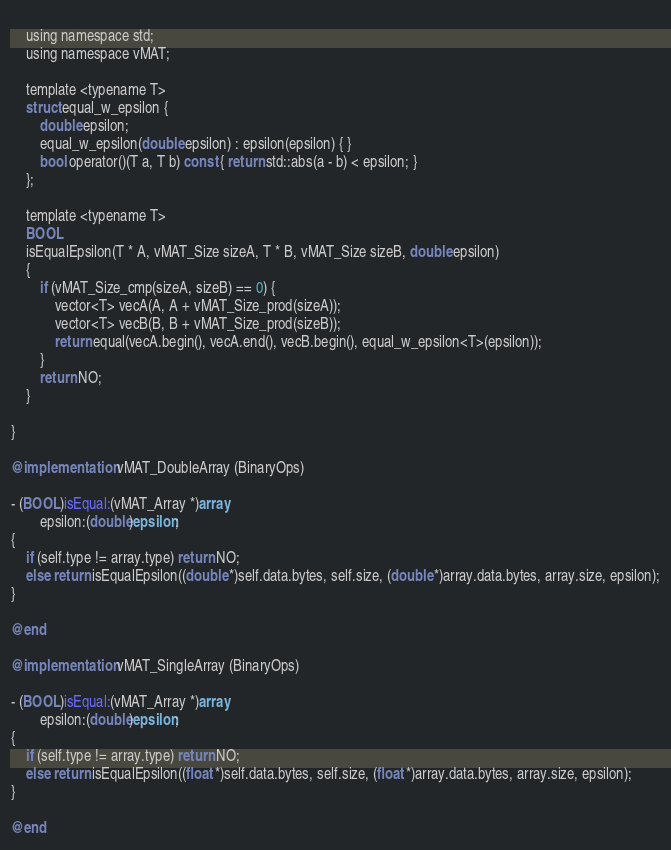Convert code to text. <code><loc_0><loc_0><loc_500><loc_500><_ObjectiveC_>    
    using namespace std;
    using namespace vMAT;
    
    template <typename T>
    struct equal_w_epsilon {
        double epsilon;
        equal_w_epsilon(double epsilon) : epsilon(epsilon) { }
        bool operator()(T a, T b) const { return std::abs(a - b) < epsilon; }
    };
    
    template <typename T>
    BOOL
    isEqualEpsilon(T * A, vMAT_Size sizeA, T * B, vMAT_Size sizeB, double epsilon)
    {
        if (vMAT_Size_cmp(sizeA, sizeB) == 0) {
            vector<T> vecA(A, A + vMAT_Size_prod(sizeA));
            vector<T> vecB(B, B + vMAT_Size_prod(sizeB));
            return equal(vecA.begin(), vecA.end(), vecB.begin(), equal_w_epsilon<T>(epsilon));
        }
        return NO;
    }
    
}

@implementation vMAT_DoubleArray (BinaryOps)

- (BOOL)isEqual:(vMAT_Array *)array
        epsilon:(double)epsilon;
{
    if (self.type != array.type) return NO;
    else return isEqualEpsilon((double *)self.data.bytes, self.size, (double *)array.data.bytes, array.size, epsilon);
}

@end

@implementation vMAT_SingleArray (BinaryOps)

- (BOOL)isEqual:(vMAT_Array *)array
        epsilon:(double)epsilon;
{
    if (self.type != array.type) return NO;
    else return isEqualEpsilon((float *)self.data.bytes, self.size, (float *)array.data.bytes, array.size, epsilon);
}

@end
</code> 